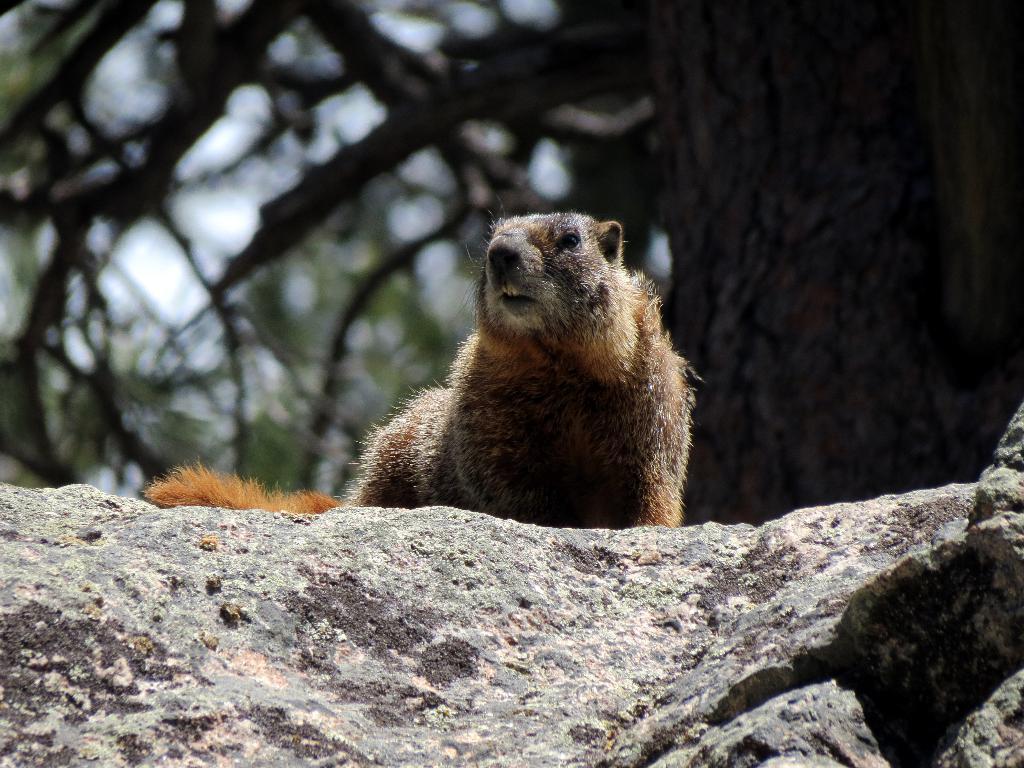Could you give a brief overview of what you see in this image? In this image I can see an animal visible on the stone and I can the tree at the top. 